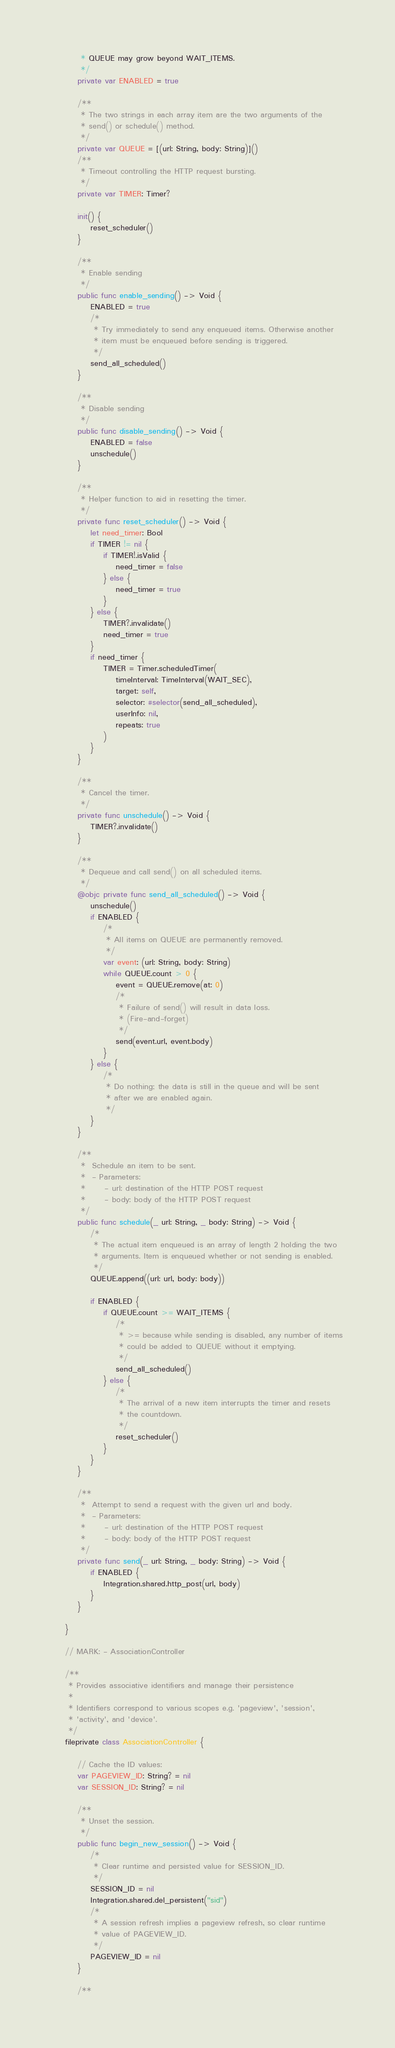<code> <loc_0><loc_0><loc_500><loc_500><_Swift_>         * QUEUE may grow beyond WAIT_ITEMS.
         */
        private var ENABLED = true

        /**
         * The two strings in each array item are the two arguments of the
         * send() or schedule() method.
         */
        private var QUEUE = [(url: String, body: String)]()
        /**
         * Timeout controlling the HTTP request bursting.
         */
        private var TIMER: Timer?

        init() {
            reset_scheduler()
        }

        /**
         * Enable sending
         */
        public func enable_sending() -> Void {
            ENABLED = true
            /*
             * Try immediately to send any enqueued items. Otherwise another
             * item must be enqueued before sending is triggered.
             */
            send_all_scheduled()
        }

        /**
         * Disable sending
         */
        public func disable_sending() -> Void {
            ENABLED = false
            unschedule()
        }

        /**
         * Helper function to aid in resetting the timer.
         */
        private func reset_scheduler() -> Void {
            let need_timer: Bool
            if TIMER != nil {
                if TIMER!.isValid {
                    need_timer = false
                } else {
                    need_timer = true
                }
            } else {
                TIMER?.invalidate()
                need_timer = true
            }
            if need_timer {
                TIMER = Timer.scheduledTimer(
                    timeInterval: TimeInterval(WAIT_SEC),
                    target: self,
                    selector: #selector(send_all_scheduled),
                    userInfo: nil,
                    repeats: true
                )
            }
        }

        /**
         * Cancel the timer.
         */
        private func unschedule() -> Void {
            TIMER?.invalidate()
        }

        /**
         * Dequeue and call send() on all scheduled items.
         */
        @objc private func send_all_scheduled() -> Void {
            unschedule()
            if ENABLED {
                /*
                 * All items on QUEUE are permanently removed.
                 */
                var event: (url: String, body: String)
                while QUEUE.count > 0 {
                    event = QUEUE.remove(at: 0)
                    /*
                     * Failure of send() will result in data loss.
                     * (Fire-and-forget)
                     */
                    send(event.url, event.body)
                }
            } else {
                /*
                 * Do nothing; the data is still in the queue and will be sent
                 * after we are enabled again.
                 */
            }
        }

        /**
         *  Schedule an item to be sent.
         *  - Parameters:
         *      - url: destination of the HTTP POST request
         *      - body: body of the HTTP POST request
         */
        public func schedule(_ url: String, _ body: String) -> Void {
            /*
             * The actual item enqueued is an array of length 2 holding the two
             * arguments. Item is enqueued whether or not sending is enabled.
             */
            QUEUE.append((url: url, body: body))

            if ENABLED {
                if QUEUE.count >= WAIT_ITEMS {
                    /*
                     * >= because while sending is disabled, any number of items
                     * could be added to QUEUE without it emptying.
                     */
                    send_all_scheduled()
                } else {
                    /*
                     * The arrival of a new item interrupts the timer and resets
                     * the countdown.
                     */
                    reset_scheduler()
                }
            }
        }

        /**
         *  Attempt to send a request with the given url and body.
         *  - Parameters:
         *      - url: destination of the HTTP POST request
         *      - body: body of the HTTP POST request
         */
        private func send(_ url: String, _ body: String) -> Void {
            if ENABLED {
                Integration.shared.http_post(url, body)
            }
        }

    }

    // MARK: - AssociationController

    /**
     * Provides associative identifiers and manage their persistence
     *
     * Identifiers correspond to various scopes e.g. 'pageview', 'session',
     * 'activity', and 'device'.
     */
    fileprivate class AssociationController {

        // Cache the ID values:
        var PAGEVIEW_ID: String? = nil
        var SESSION_ID: String? = nil

        /**
         * Unset the session.
         */
        public func begin_new_session() -> Void {
            /*
             * Clear runtime and persisted value for SESSION_ID.
             */
            SESSION_ID = nil
            Integration.shared.del_persistent("sid")
            /*
             * A session refresh implies a pageview refresh, so clear runtime
             * value of PAGEVIEW_ID.
             */
            PAGEVIEW_ID = nil
        }

        /**</code> 